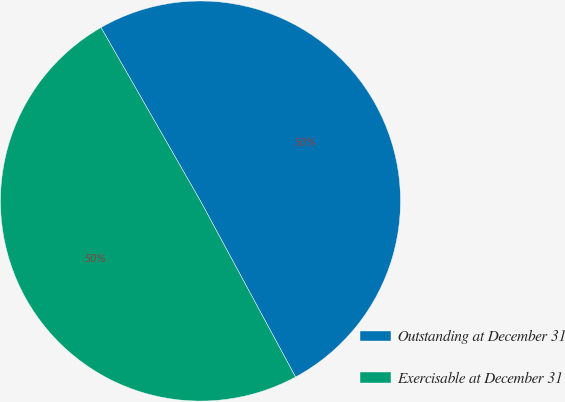Convert chart to OTSL. <chart><loc_0><loc_0><loc_500><loc_500><pie_chart><fcel>Outstanding at December 31<fcel>Exercisable at December 31<nl><fcel>50.4%<fcel>49.6%<nl></chart> 